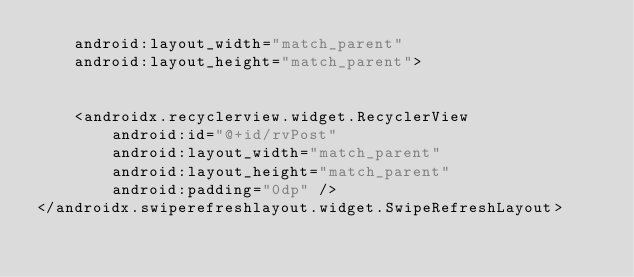<code> <loc_0><loc_0><loc_500><loc_500><_XML_>    android:layout_width="match_parent"
    android:layout_height="match_parent">


    <androidx.recyclerview.widget.RecyclerView
        android:id="@+id/rvPost"
        android:layout_width="match_parent"
        android:layout_height="match_parent"
        android:padding="0dp" />
</androidx.swiperefreshlayout.widget.SwipeRefreshLayout></code> 